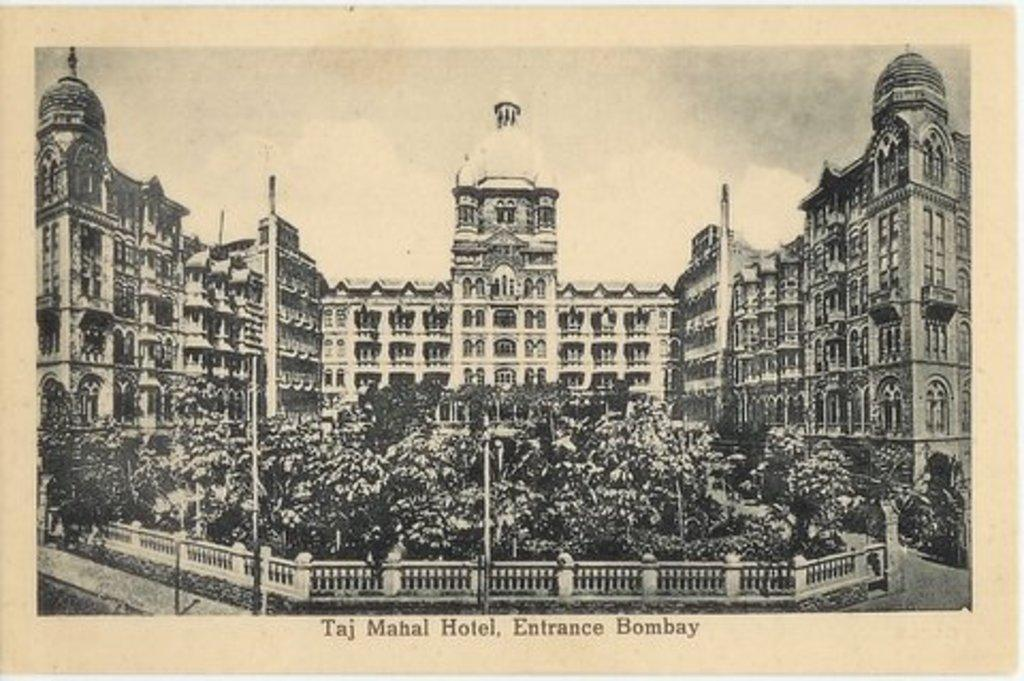<image>
Provide a brief description of the given image. A black and white print of the Taj Mahal Hotel viewed from the Bombay Entrance. 